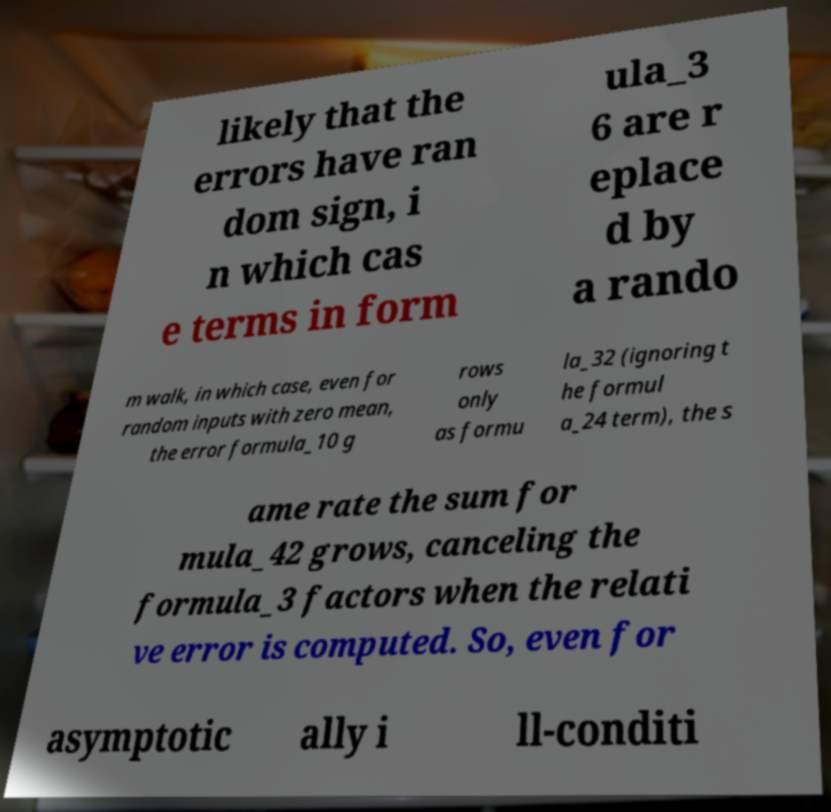Could you assist in decoding the text presented in this image and type it out clearly? likely that the errors have ran dom sign, i n which cas e terms in form ula_3 6 are r eplace d by a rando m walk, in which case, even for random inputs with zero mean, the error formula_10 g rows only as formu la_32 (ignoring t he formul a_24 term), the s ame rate the sum for mula_42 grows, canceling the formula_3 factors when the relati ve error is computed. So, even for asymptotic ally i ll-conditi 